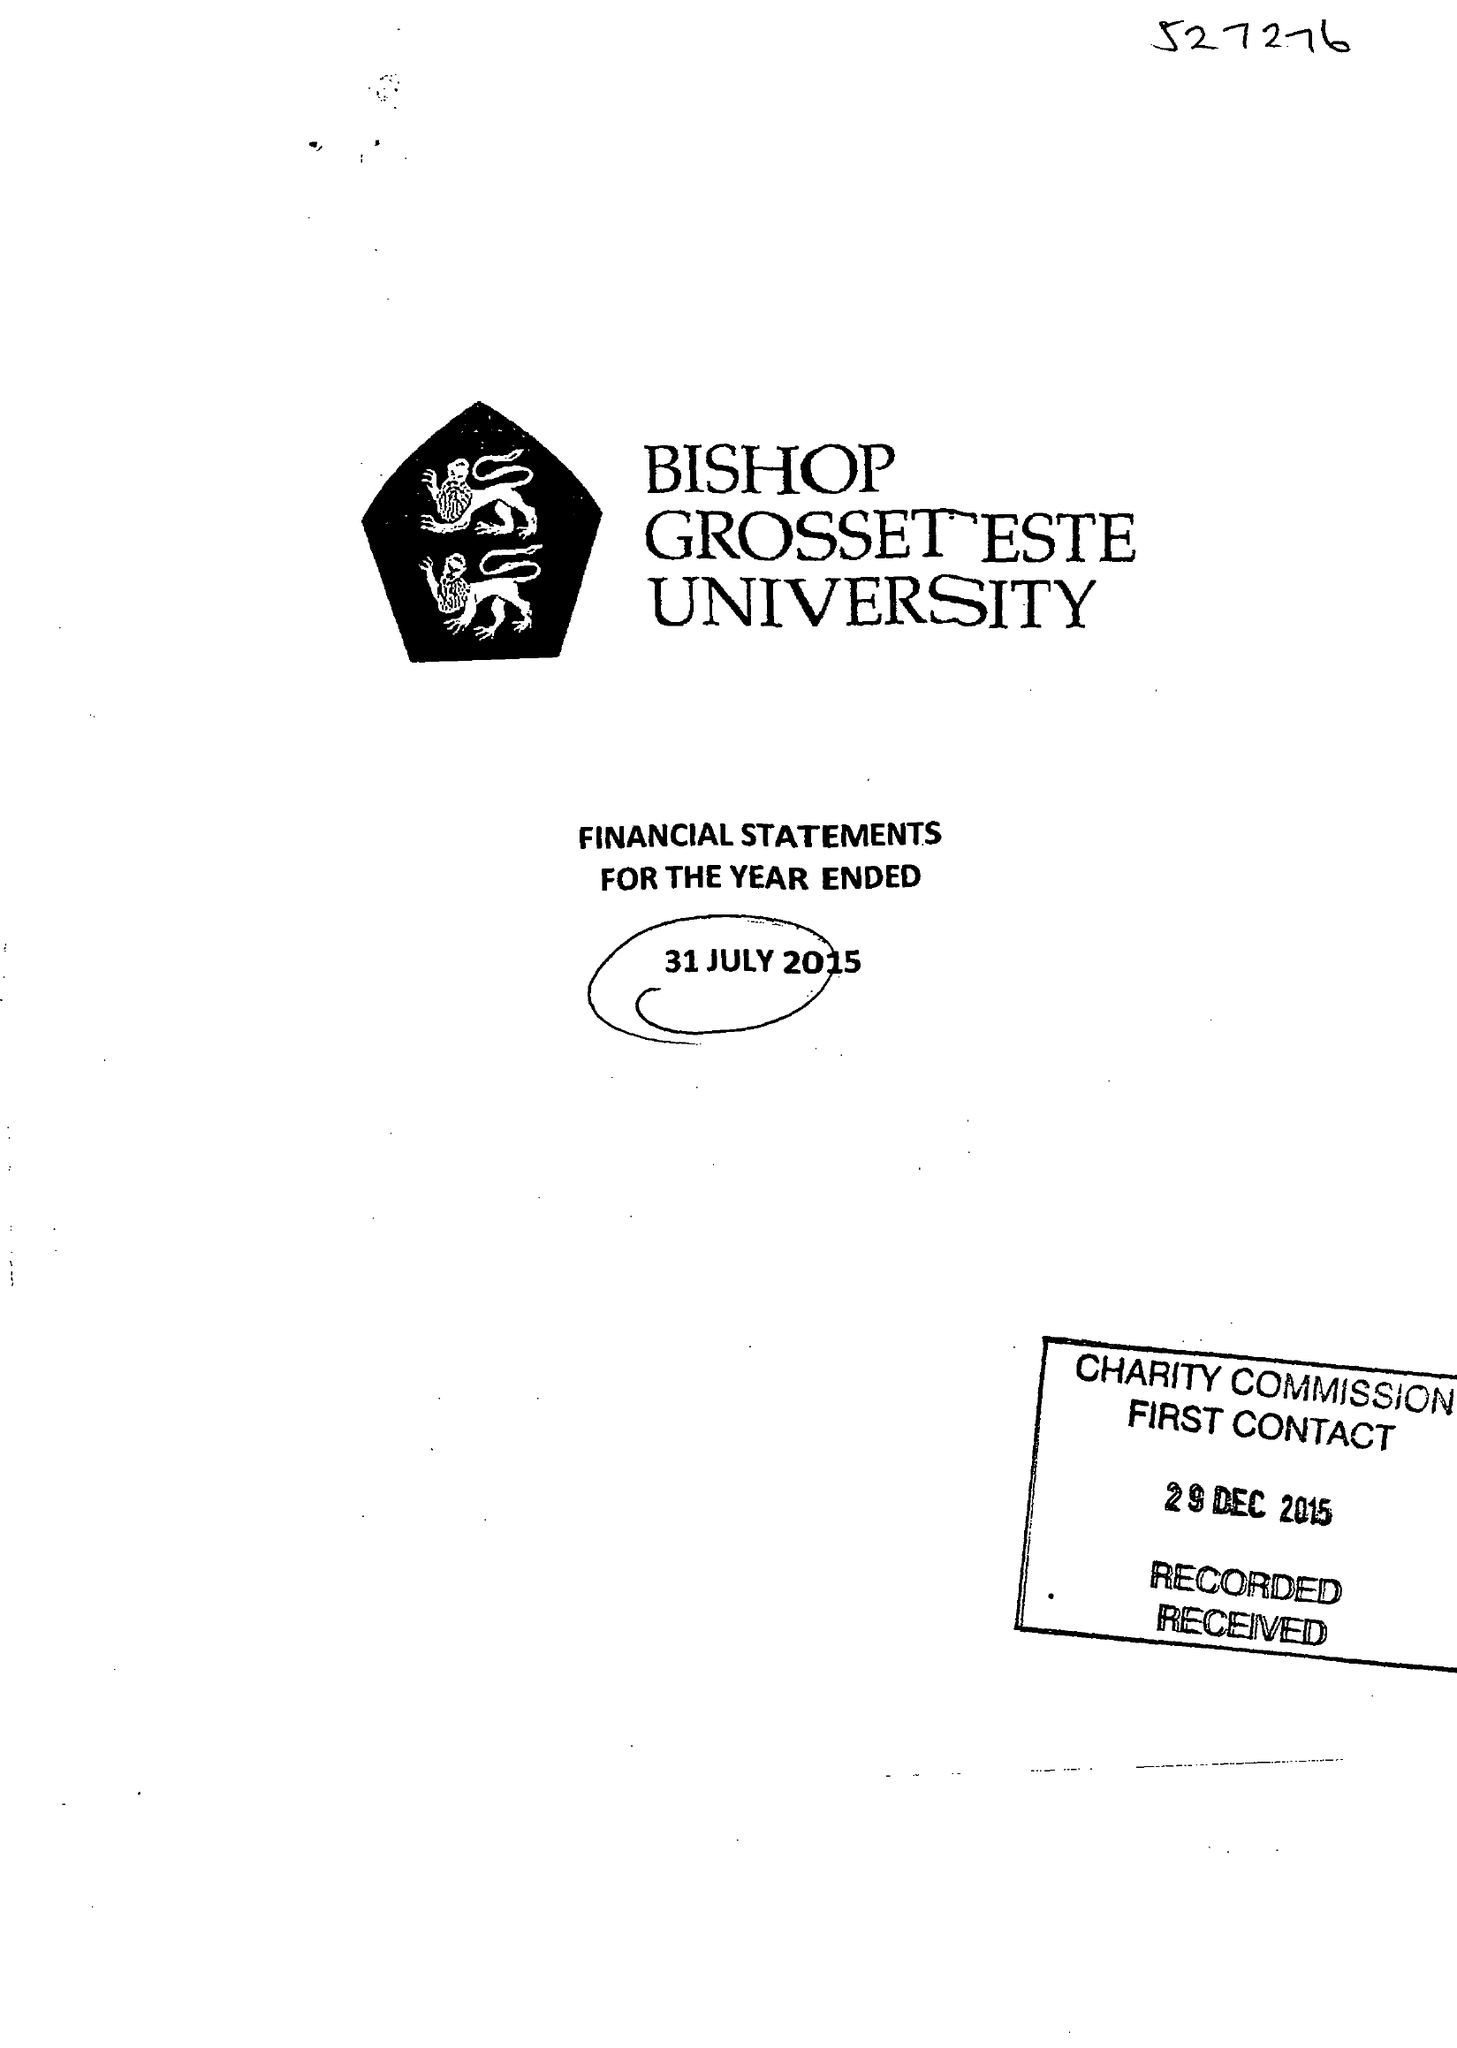What is the value for the address__street_line?
Answer the question using a single word or phrase. LONGDALES ROAD 